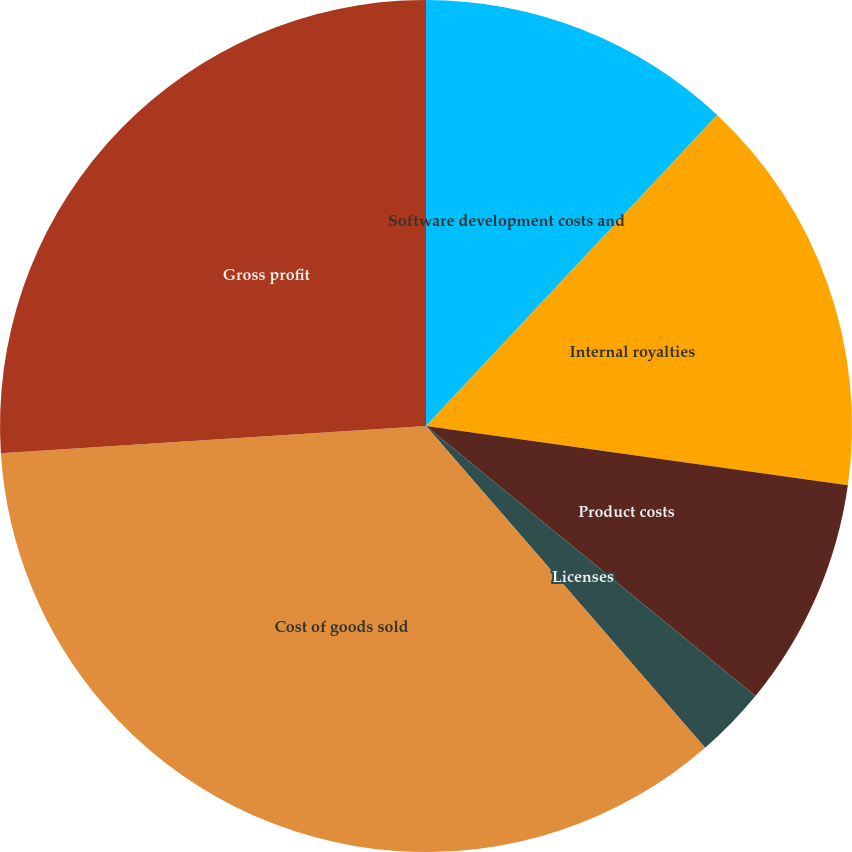Convert chart to OTSL. <chart><loc_0><loc_0><loc_500><loc_500><pie_chart><fcel>Software development costs and<fcel>Internal royalties<fcel>Product costs<fcel>Licenses<fcel>Cost of goods sold<fcel>Gross profit<nl><fcel>11.98%<fcel>15.24%<fcel>8.71%<fcel>2.7%<fcel>35.35%<fcel>26.02%<nl></chart> 